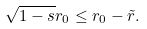<formula> <loc_0><loc_0><loc_500><loc_500>\sqrt { 1 - s } r _ { 0 } \leq r _ { 0 } - \tilde { r } .</formula> 